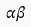<formula> <loc_0><loc_0><loc_500><loc_500>\alpha \dot { \beta }</formula> 